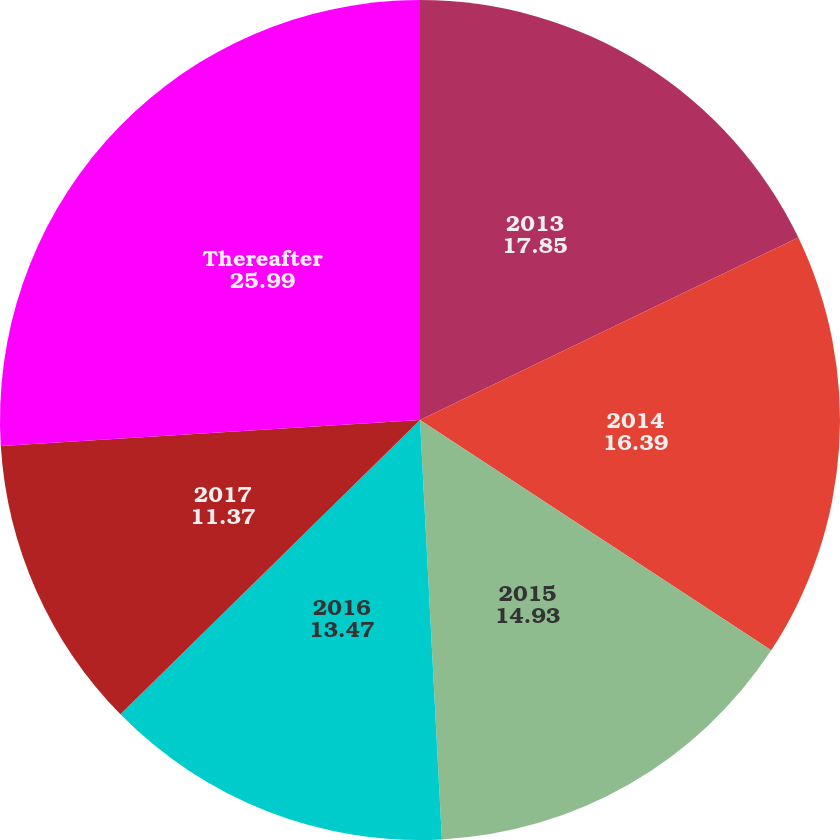Convert chart. <chart><loc_0><loc_0><loc_500><loc_500><pie_chart><fcel>2013<fcel>2014<fcel>2015<fcel>2016<fcel>2017<fcel>Thereafter<nl><fcel>17.85%<fcel>16.39%<fcel>14.93%<fcel>13.47%<fcel>11.37%<fcel>25.99%<nl></chart> 